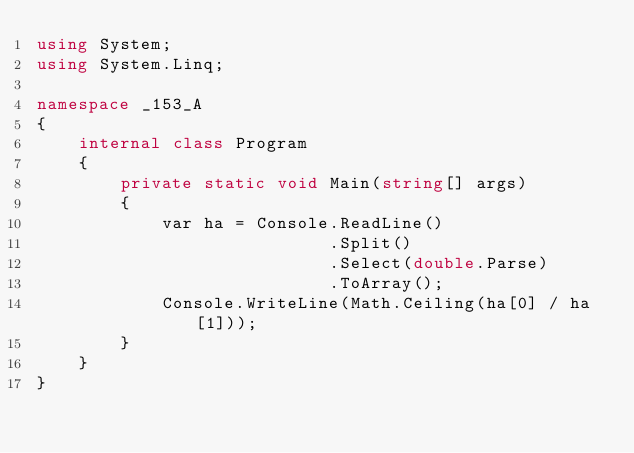Convert code to text. <code><loc_0><loc_0><loc_500><loc_500><_C#_>using System;
using System.Linq;

namespace _153_A
{
    internal class Program
    {
        private static void Main(string[] args)
        {
            var ha = Console.ReadLine()
                            .Split()
                            .Select(double.Parse)
                            .ToArray();
            Console.WriteLine(Math.Ceiling(ha[0] / ha[1]));
        }
    }
}</code> 